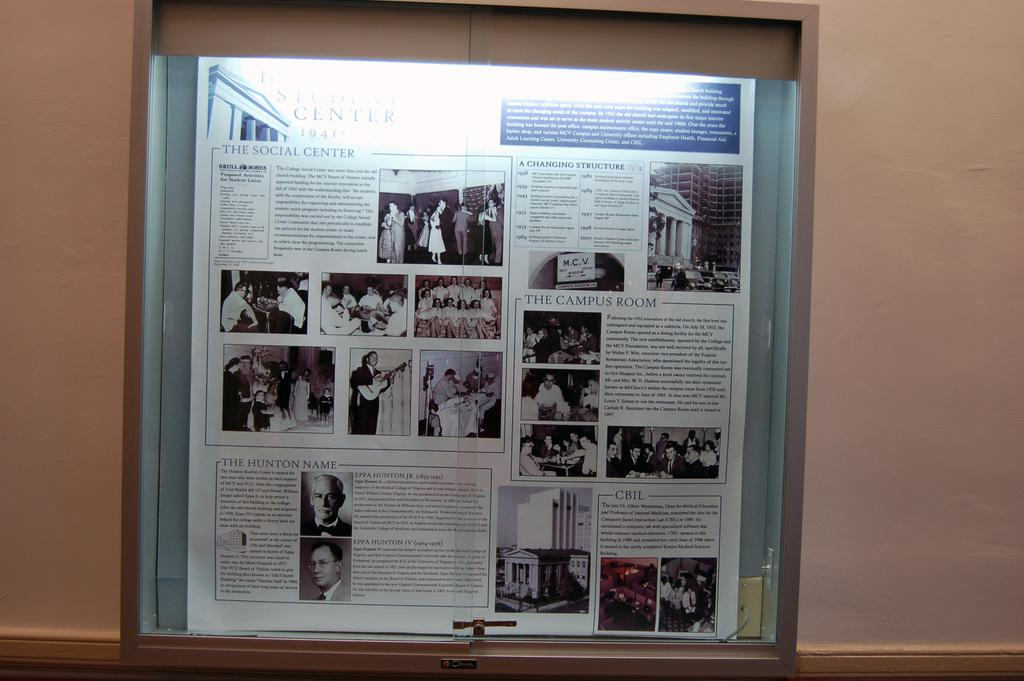Provide a one-sentence caption for the provided image. The year of the book states it's from 1941. 